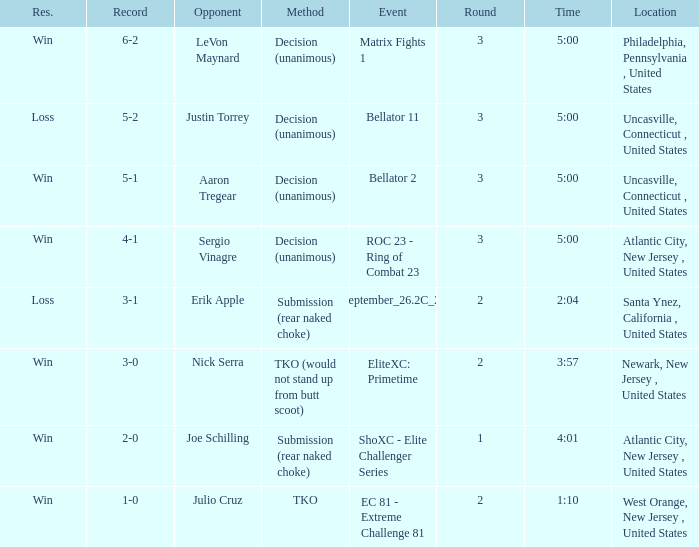Who was the competitor when the tko method took place? Julio Cruz. 